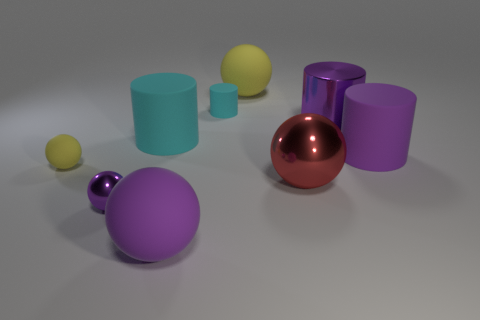Subtract all red balls. How many balls are left? 4 Subtract 1 cylinders. How many cylinders are left? 3 Subtract all large purple matte spheres. How many spheres are left? 4 Subtract all brown balls. Subtract all brown blocks. How many balls are left? 5 Subtract all spheres. How many objects are left? 4 Add 6 rubber cylinders. How many rubber cylinders are left? 9 Add 9 tiny brown rubber cylinders. How many tiny brown rubber cylinders exist? 9 Subtract 1 purple cylinders. How many objects are left? 8 Subtract all small purple shiny spheres. Subtract all small matte objects. How many objects are left? 6 